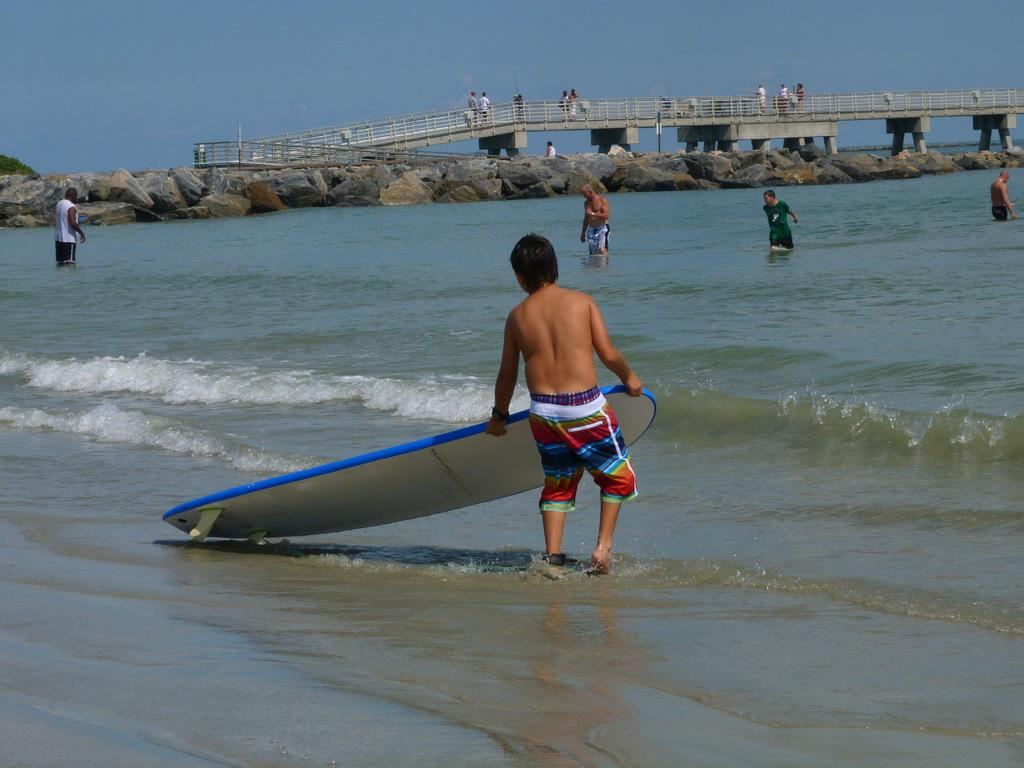How many people are in the image? There is a group of people in the image. Where are some of the people located in the image? Some people are in the water, and some are on a bridge. Can you describe the setting of the image? The image features a group of people near water, with some in the water and others on a bridge. How many babies are sitting on the card in the image? There are no babies or cards present in the image. 